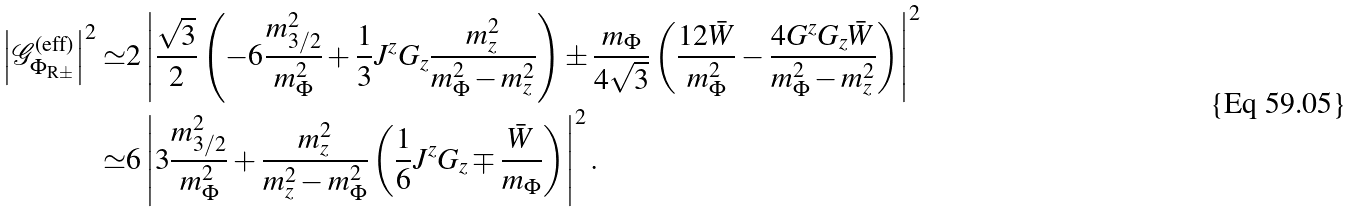<formula> <loc_0><loc_0><loc_500><loc_500>\left | \mathcal { G } ^ { \text {(eff)} } _ { \Phi _ { \text {R} \pm } } \right | ^ { 2 } \simeq & 2 \left | \frac { \sqrt { 3 } } { 2 } \left ( - 6 \frac { m _ { 3 / 2 } ^ { 2 } } { m _ { \Phi } ^ { 2 } } + \frac { 1 } { 3 } J ^ { z } G _ { z } \frac { m _ { z } ^ { 2 } } { m _ { \Phi } ^ { 2 } - m _ { z } ^ { 2 } } \right ) \pm \frac { m _ { \Phi } } { 4 \sqrt { 3 } } \left ( \frac { 1 2 \bar { W } } { m _ { \Phi } ^ { 2 } } - \frac { 4 G ^ { z } G _ { z } \bar { W } } { m _ { \Phi } ^ { 2 } - m _ { z } ^ { 2 } } \right ) \right | ^ { 2 } \\ \simeq & 6 \left | 3 \frac { m _ { 3 / 2 } ^ { 2 } } { m _ { \Phi } ^ { 2 } } + \frac { m _ { z } ^ { 2 } } { m _ { z } ^ { 2 } - m _ { \Phi } ^ { 2 } } \left ( \frac { 1 } { 6 } J ^ { z } G _ { z } \mp \frac { \bar { W } } { m _ { \Phi } } \right ) \right | ^ { 2 } .</formula> 